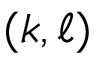<formula> <loc_0><loc_0><loc_500><loc_500>( k , \ell )</formula> 